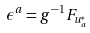Convert formula to latex. <formula><loc_0><loc_0><loc_500><loc_500>\epsilon ^ { a } = g ^ { - 1 } F _ { u ^ { * } _ { a } }</formula> 